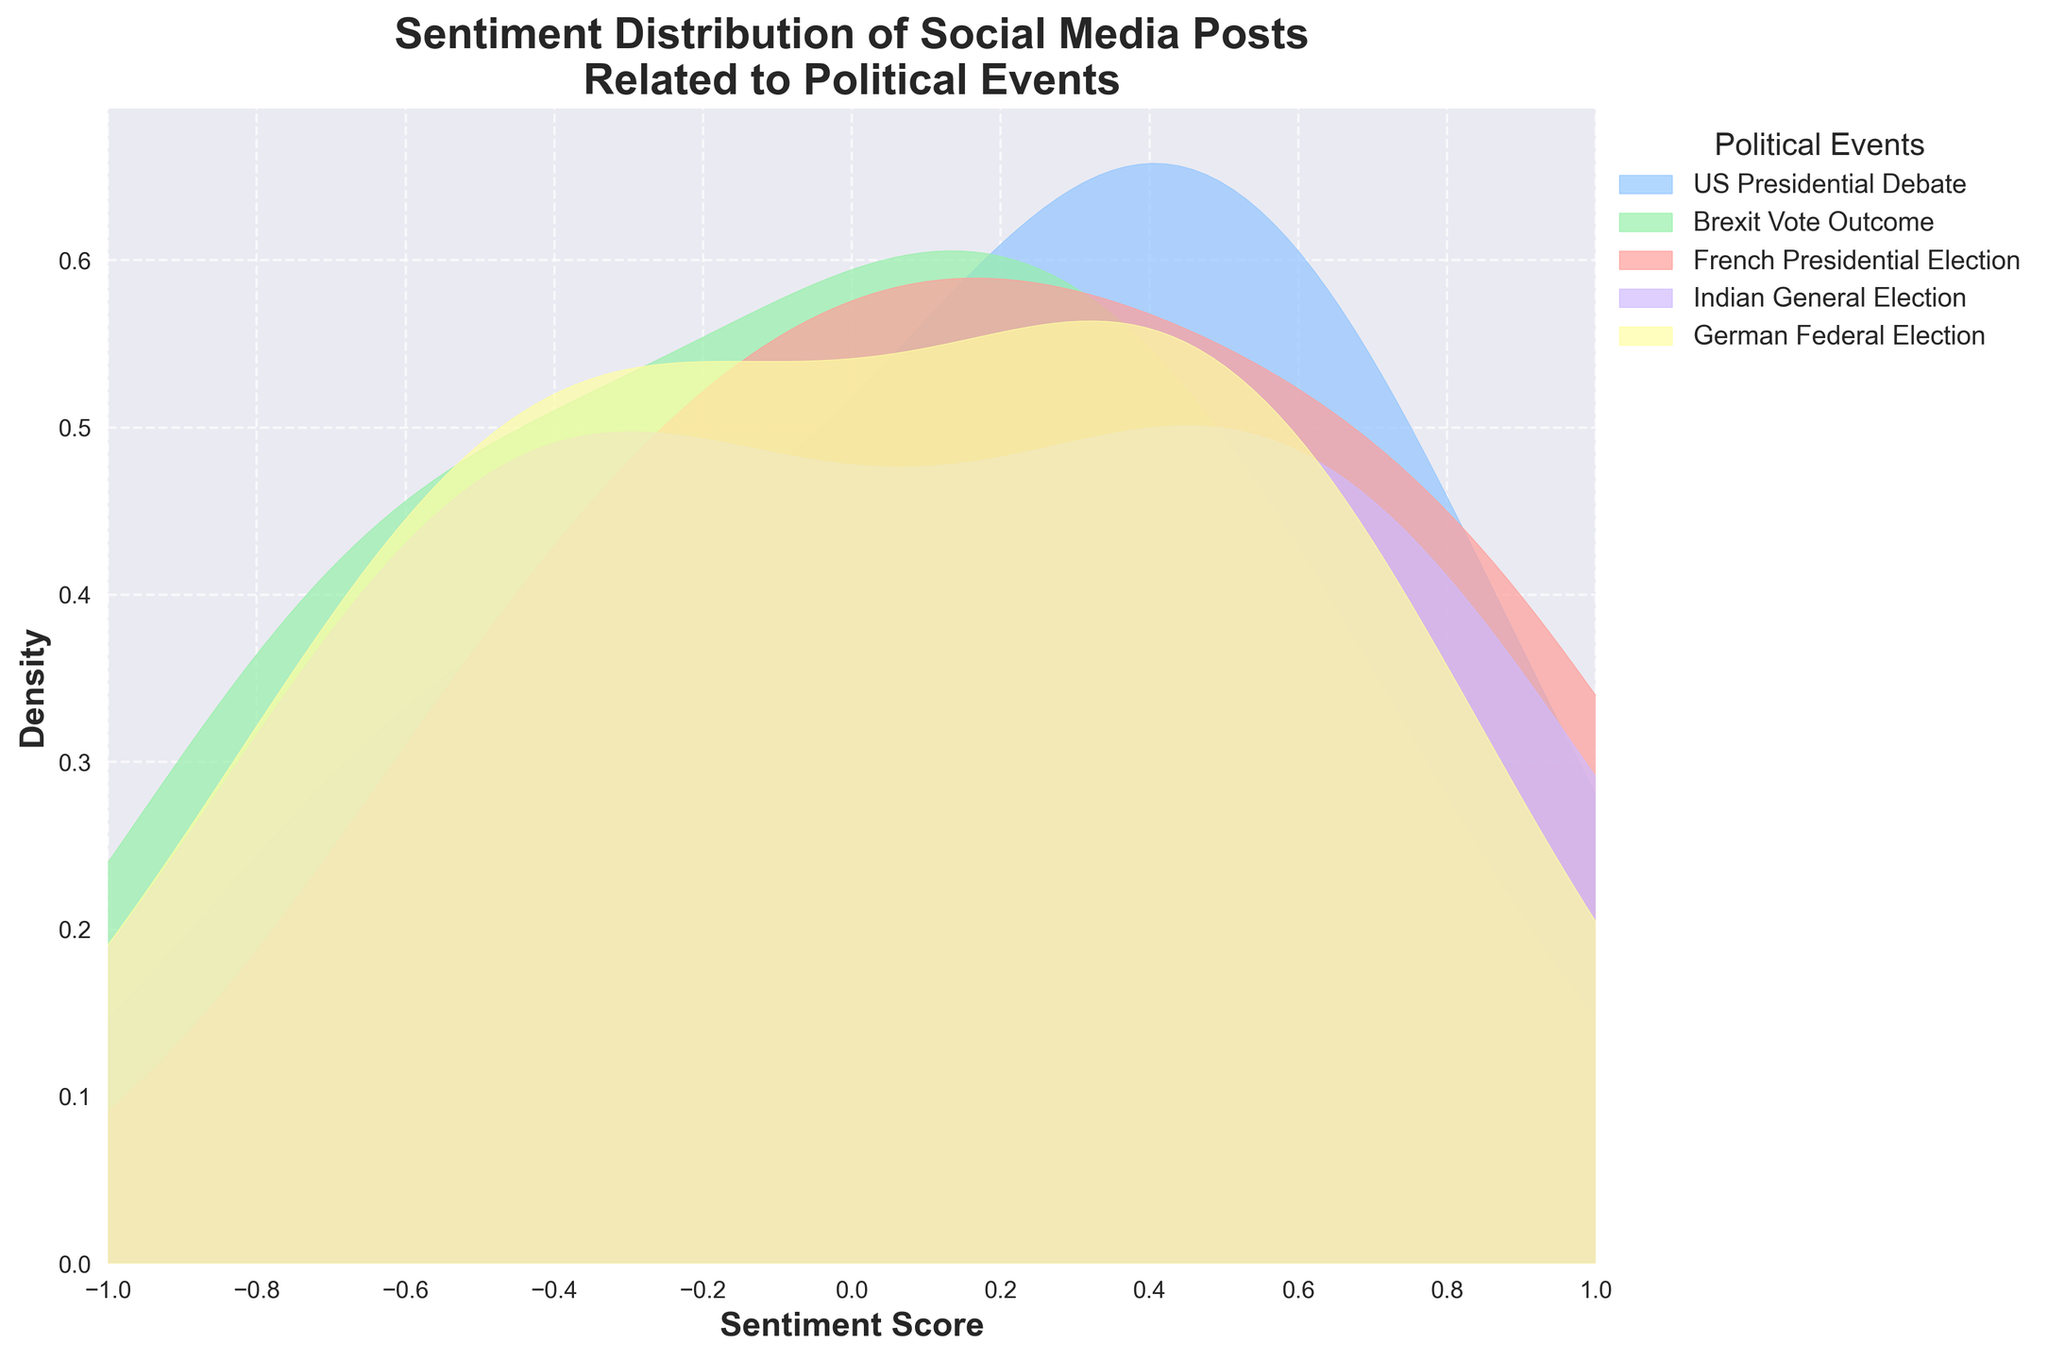What's the title of the figure? The title of the figure is located at the top and reads "Sentiment Distribution of Social Media Posts Related to Political Events."
Answer: Sentiment Distribution of Social Media Posts Related to Political Events What are the x-axis and y-axis labels? The x-axis is labeled "Sentiment Score," and the y-axis is labeled "Density." These labels are specified on the respective axes.
Answer: Sentiment Score, Density Which event has the highest density peak? By looking for the event curve that peaks the highest along the y-axis, we can identify that the US Presidential Debate has the highest density peak.
Answer: US Presidential Debate What is the x-axis range of the figure? The x-axis limits are marked from -1 to 1.
Answer: -1 to 1 How many major political events are represented in the plot? The legend on the right side of the plot lists all the plotted events: US Presidential Debate, Brexit Vote Outcome, French Presidential Election, Indian General Election, and German Federal Election.
Answer: 5 Which event shows the widest distribution of sentiment scores? The event with the widest distribution will have a density curve that spans more of the x-axis; this appears to be the German Federal Election which ranges widely across negative and positive sentiment scores.
Answer: German Federal Election Are there any events with a near-zero sentiment score density peak? Yes, the Brexit Vote Outcome has a peak close to a zero sentiment score.
Answer: Brexit Vote Outcome How do the sentiment scores of US Presidential Debate and Brexit Vote Outcome compare? Both events have peaks around centralized sentiment scores; however, the US Presidential Debate peaks significantly higher while the Brexit Vote Outcome peak is lower and closer to zero sentiment score.
Answer: US Presidential Debate peaks higher, Brexit Vote Outcome lower around zero Which event has the most positive sentiment distribution? The event with the highest peak in the positive range (right-hand side of the x-axis) is the US Presidential Debate.
Answer: US Presidential Debate What is the sentiment score range where the French Presidential Election has noticeable density? The French Presidential Election shows a density spread across the range of approximately -0.5 to 0.9 on the sentiment score.
Answer: -0.5 to 0.9 